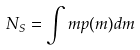Convert formula to latex. <formula><loc_0><loc_0><loc_500><loc_500>N _ { S } = \int m p ( m ) d m</formula> 